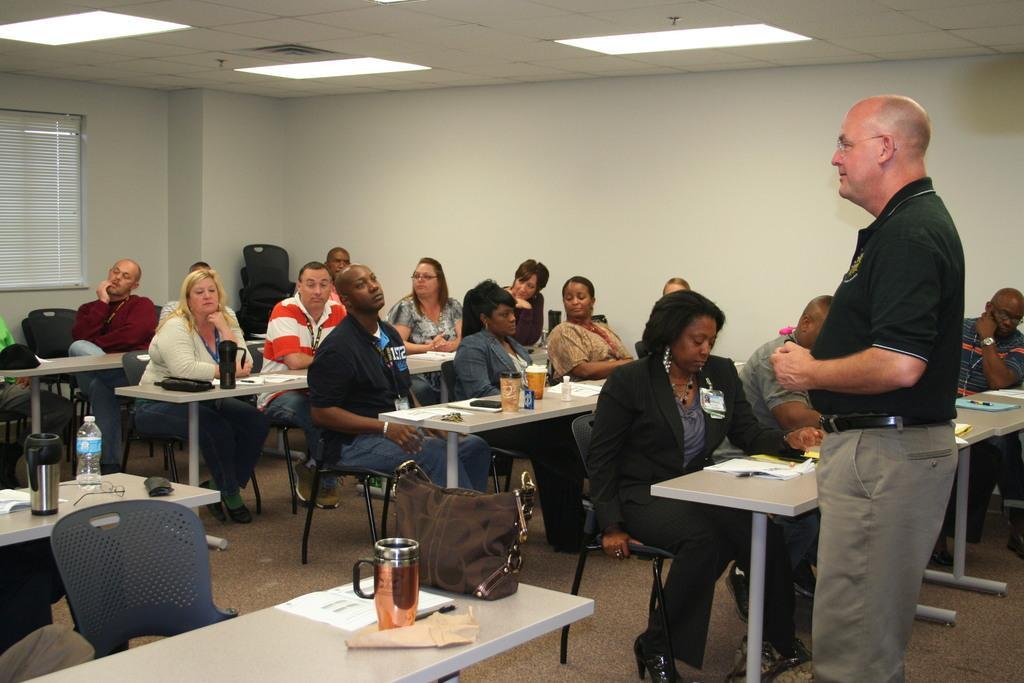Could you give a brief overview of what you see in this image? At the top there is ceiling and lights. This is a wall and empty chairs. we can see all the persons sitting on chairs infront of a table and on the table we can seeglasses, mugs, water bottles, spectacles, handbag. We can see one man standing here. He wore spectacles. 